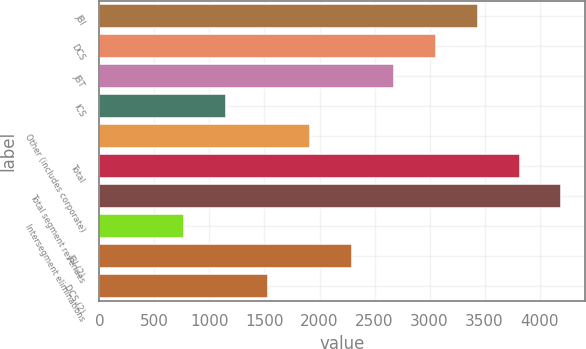Convert chart to OTSL. <chart><loc_0><loc_0><loc_500><loc_500><bar_chart><fcel>JBI<fcel>DCS<fcel>JBT<fcel>ICS<fcel>Other (includes corporate)<fcel>Total<fcel>Total segment revenues<fcel>Intersegment eliminations<fcel>JBI (2)<fcel>DCS (2)<nl><fcel>3437.2<fcel>3056.4<fcel>2675.6<fcel>1152.4<fcel>1914<fcel>3818<fcel>4198.8<fcel>771.6<fcel>2294.8<fcel>1533.2<nl></chart> 